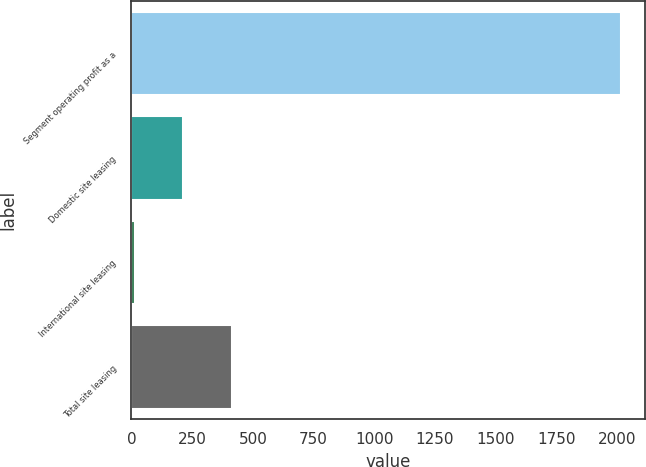<chart> <loc_0><loc_0><loc_500><loc_500><bar_chart><fcel>Segment operating profit as a<fcel>Domestic site leasing<fcel>International site leasing<fcel>Total site leasing<nl><fcel>2014<fcel>213.55<fcel>13.5<fcel>413.6<nl></chart> 